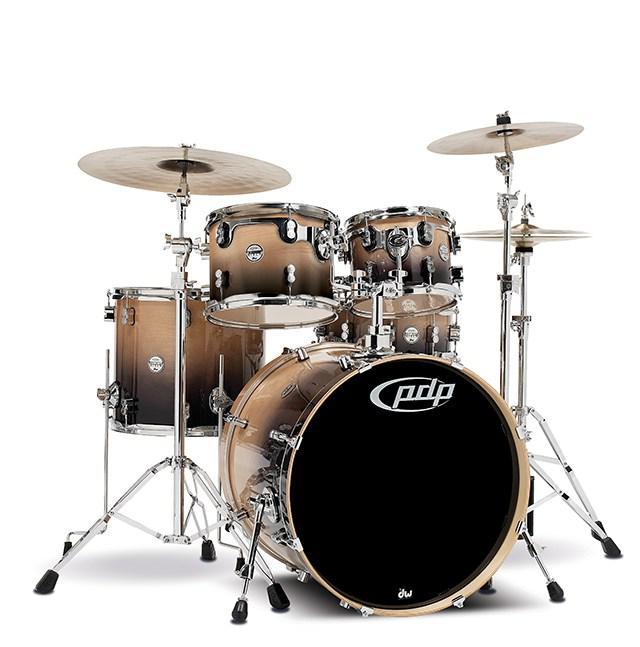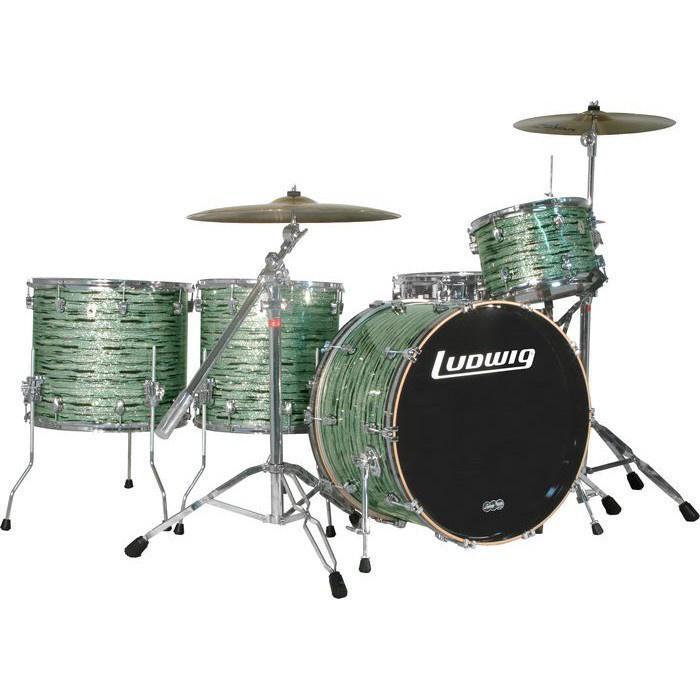The first image is the image on the left, the second image is the image on the right. Analyze the images presented: Is the assertion "In at least one image there are five blue drums." valid? Answer yes or no. No. The first image is the image on the left, the second image is the image on the right. Considering the images on both sides, is "The drum kits on the left and right each have exactly one large central drum that stands with a side facing the front, and that exposed side has the same color in each image." valid? Answer yes or no. Yes. 